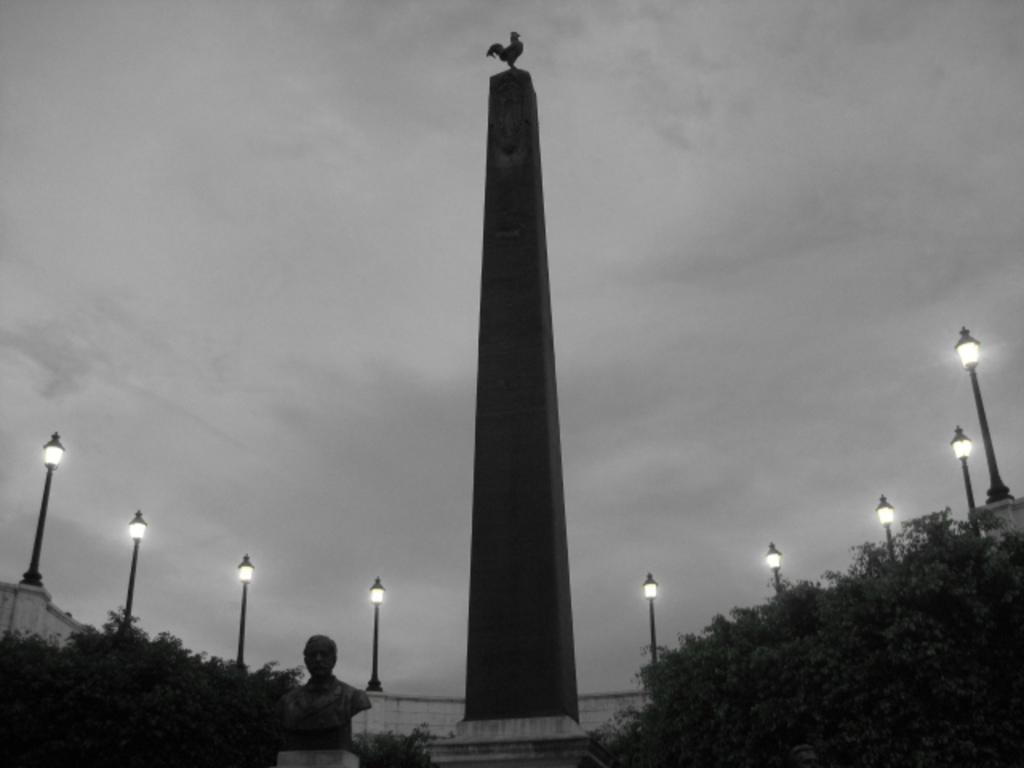What is the main structure in the picture? There is a tower in the picture. What other object can be seen in the picture? There is a sculpture in the picture. What type of natural elements are present around the tower and sculpture? There are trees around the tower and sculpture. What can be seen illuminating the area in the picture? There are lights visible in the picture. What type of furniture is visible in the picture? There is no furniture present in the picture. What color is the powder on the back of the sculpture? There is no powder or mention of a back on the sculpture in the picture. 